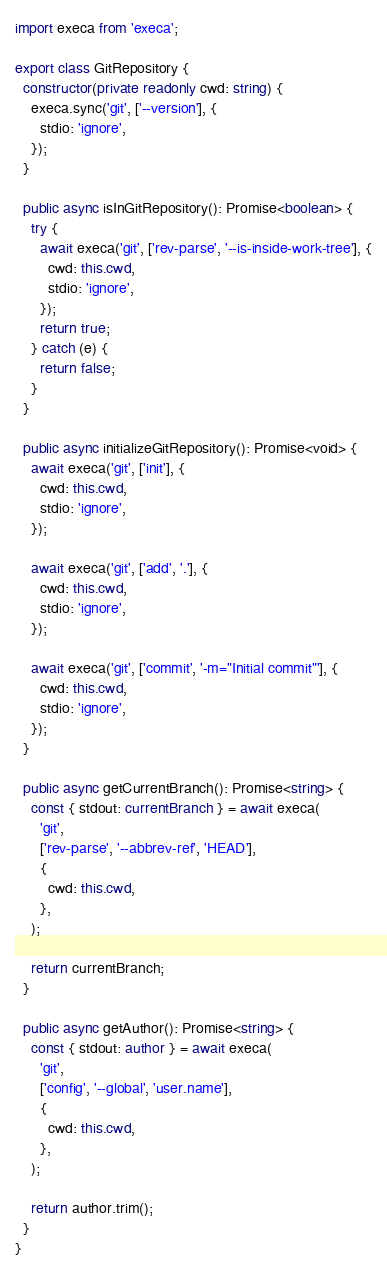<code> <loc_0><loc_0><loc_500><loc_500><_TypeScript_>import execa from 'execa';

export class GitRepository {
  constructor(private readonly cwd: string) {
    execa.sync('git', ['--version'], {
      stdio: 'ignore',
    });
  }

  public async isInGitRepository(): Promise<boolean> {
    try {
      await execa('git', ['rev-parse', '--is-inside-work-tree'], {
        cwd: this.cwd,
        stdio: 'ignore',
      });
      return true;
    } catch (e) {
      return false;
    }
  }

  public async initializeGitRepository(): Promise<void> {
    await execa('git', ['init'], {
      cwd: this.cwd,
      stdio: 'ignore',
    });

    await execa('git', ['add', '.'], {
      cwd: this.cwd,
      stdio: 'ignore',
    });

    await execa('git', ['commit', '-m="Initial commit"'], {
      cwd: this.cwd,
      stdio: 'ignore',
    });
  }

  public async getCurrentBranch(): Promise<string> {
    const { stdout: currentBranch } = await execa(
      'git',
      ['rev-parse', '--abbrev-ref', 'HEAD'],
      {
        cwd: this.cwd,
      },
    );

    return currentBranch;
  }

  public async getAuthor(): Promise<string> {
    const { stdout: author } = await execa(
      'git',
      ['config', '--global', 'user.name'],
      {
        cwd: this.cwd,
      },
    );

    return author.trim();
  }
}
</code> 